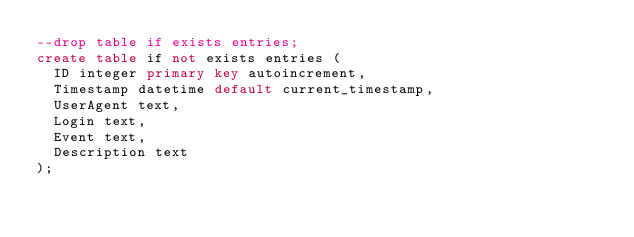<code> <loc_0><loc_0><loc_500><loc_500><_SQL_>--drop table if exists entries;
create table if not exists entries (
  ID integer primary key autoincrement,
  Timestamp datetime default current_timestamp,
  UserAgent text,
  Login text,
  Event text,
  Description text
);</code> 